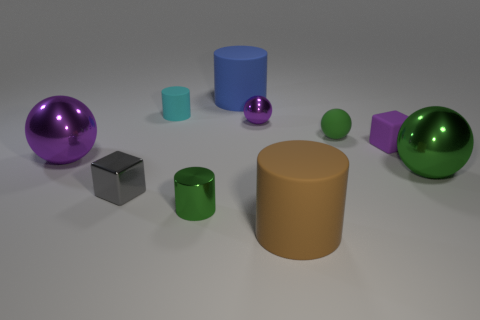Is there a cyan cylinder of the same size as the matte block?
Your response must be concise. Yes. The large thing in front of the green shiny thing on the left side of the large green shiny ball is what color?
Make the answer very short. Brown. What number of green cylinders are there?
Your response must be concise. 1. Do the matte ball and the small metallic ball have the same color?
Your answer should be very brief. No. Is the number of green things that are behind the small purple metal sphere less than the number of big green objects in front of the purple rubber cube?
Provide a short and direct response. Yes. What is the color of the metal block?
Your response must be concise. Gray. What number of small matte blocks have the same color as the small metallic ball?
Offer a terse response. 1. Are there any big spheres to the left of the small rubber ball?
Your answer should be compact. Yes. Are there an equal number of large blue objects in front of the blue thing and purple spheres that are to the left of the small green cylinder?
Your response must be concise. No. There is a purple metal object that is behind the tiny purple cube; does it have the same size as the green rubber thing in front of the cyan matte object?
Offer a very short reply. Yes. 